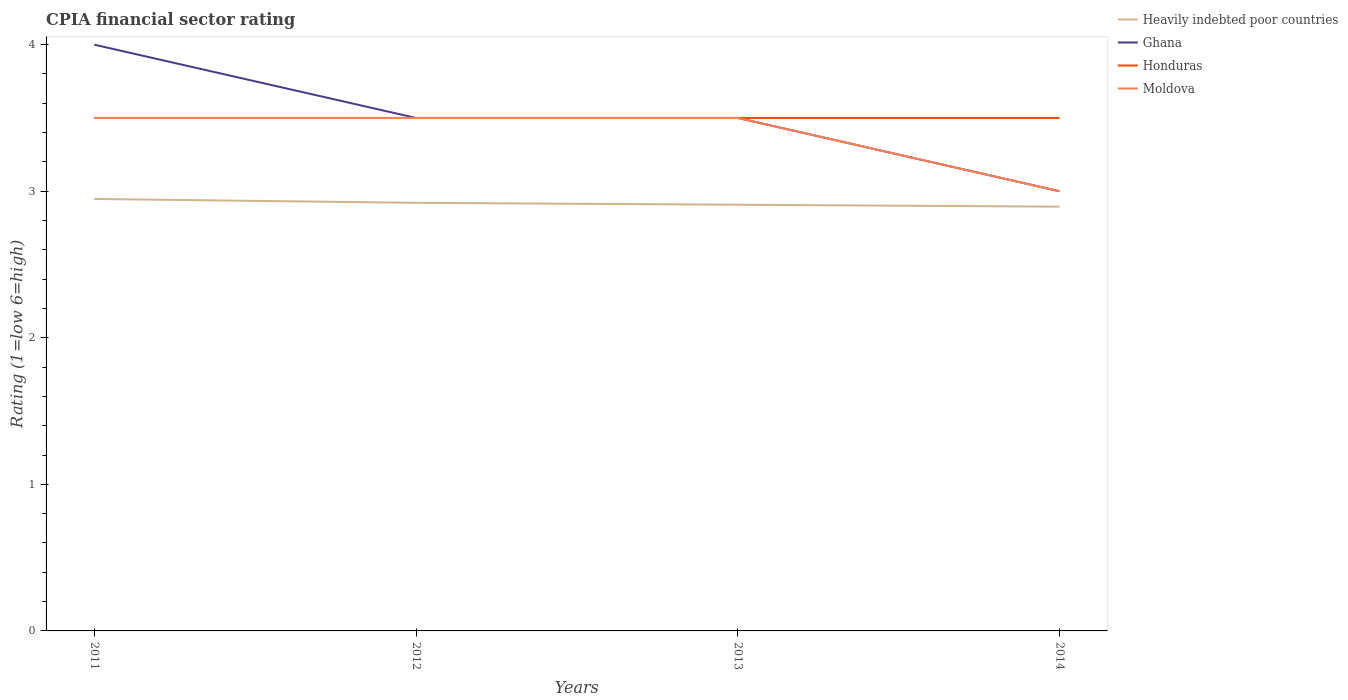How many different coloured lines are there?
Your response must be concise. 4. Does the line corresponding to Honduras intersect with the line corresponding to Moldova?
Keep it short and to the point. Yes. What is the total CPIA rating in Moldova in the graph?
Keep it short and to the point. 0. What is the difference between the highest and the second highest CPIA rating in Ghana?
Ensure brevity in your answer.  1. What is the difference between the highest and the lowest CPIA rating in Honduras?
Keep it short and to the point. 0. Is the CPIA rating in Moldova strictly greater than the CPIA rating in Honduras over the years?
Ensure brevity in your answer.  No. How many lines are there?
Ensure brevity in your answer.  4. Does the graph contain any zero values?
Offer a very short reply. No. Where does the legend appear in the graph?
Offer a very short reply. Top right. How many legend labels are there?
Your response must be concise. 4. What is the title of the graph?
Ensure brevity in your answer.  CPIA financial sector rating. Does "Greenland" appear as one of the legend labels in the graph?
Your response must be concise. No. What is the label or title of the X-axis?
Your response must be concise. Years. What is the label or title of the Y-axis?
Ensure brevity in your answer.  Rating (1=low 6=high). What is the Rating (1=low 6=high) of Heavily indebted poor countries in 2011?
Provide a succinct answer. 2.95. What is the Rating (1=low 6=high) in Ghana in 2011?
Offer a very short reply. 4. What is the Rating (1=low 6=high) of Heavily indebted poor countries in 2012?
Ensure brevity in your answer.  2.92. What is the Rating (1=low 6=high) in Ghana in 2012?
Provide a succinct answer. 3.5. What is the Rating (1=low 6=high) of Honduras in 2012?
Provide a succinct answer. 3.5. What is the Rating (1=low 6=high) in Moldova in 2012?
Provide a succinct answer. 3.5. What is the Rating (1=low 6=high) in Heavily indebted poor countries in 2013?
Ensure brevity in your answer.  2.91. What is the Rating (1=low 6=high) in Moldova in 2013?
Offer a very short reply. 3.5. What is the Rating (1=low 6=high) in Heavily indebted poor countries in 2014?
Offer a terse response. 2.89. What is the Rating (1=low 6=high) in Honduras in 2014?
Make the answer very short. 3.5. Across all years, what is the maximum Rating (1=low 6=high) in Heavily indebted poor countries?
Offer a terse response. 2.95. Across all years, what is the maximum Rating (1=low 6=high) in Ghana?
Provide a succinct answer. 4. Across all years, what is the maximum Rating (1=low 6=high) of Honduras?
Offer a very short reply. 3.5. Across all years, what is the minimum Rating (1=low 6=high) in Heavily indebted poor countries?
Ensure brevity in your answer.  2.89. Across all years, what is the minimum Rating (1=low 6=high) of Ghana?
Ensure brevity in your answer.  3. Across all years, what is the minimum Rating (1=low 6=high) in Moldova?
Provide a short and direct response. 3. What is the total Rating (1=low 6=high) in Heavily indebted poor countries in the graph?
Keep it short and to the point. 11.67. What is the difference between the Rating (1=low 6=high) of Heavily indebted poor countries in 2011 and that in 2012?
Your answer should be compact. 0.03. What is the difference between the Rating (1=low 6=high) of Honduras in 2011 and that in 2012?
Provide a succinct answer. 0. What is the difference between the Rating (1=low 6=high) of Moldova in 2011 and that in 2012?
Offer a very short reply. 0. What is the difference between the Rating (1=low 6=high) in Heavily indebted poor countries in 2011 and that in 2013?
Offer a terse response. 0.04. What is the difference between the Rating (1=low 6=high) of Honduras in 2011 and that in 2013?
Offer a terse response. 0. What is the difference between the Rating (1=low 6=high) in Heavily indebted poor countries in 2011 and that in 2014?
Offer a terse response. 0.05. What is the difference between the Rating (1=low 6=high) in Heavily indebted poor countries in 2012 and that in 2013?
Ensure brevity in your answer.  0.01. What is the difference between the Rating (1=low 6=high) in Moldova in 2012 and that in 2013?
Ensure brevity in your answer.  0. What is the difference between the Rating (1=low 6=high) in Heavily indebted poor countries in 2012 and that in 2014?
Your answer should be very brief. 0.03. What is the difference between the Rating (1=low 6=high) of Ghana in 2012 and that in 2014?
Your answer should be very brief. 0.5. What is the difference between the Rating (1=low 6=high) in Heavily indebted poor countries in 2013 and that in 2014?
Your answer should be very brief. 0.01. What is the difference between the Rating (1=low 6=high) in Heavily indebted poor countries in 2011 and the Rating (1=low 6=high) in Ghana in 2012?
Your answer should be very brief. -0.55. What is the difference between the Rating (1=low 6=high) of Heavily indebted poor countries in 2011 and the Rating (1=low 6=high) of Honduras in 2012?
Offer a very short reply. -0.55. What is the difference between the Rating (1=low 6=high) of Heavily indebted poor countries in 2011 and the Rating (1=low 6=high) of Moldova in 2012?
Make the answer very short. -0.55. What is the difference between the Rating (1=low 6=high) of Ghana in 2011 and the Rating (1=low 6=high) of Honduras in 2012?
Provide a succinct answer. 0.5. What is the difference between the Rating (1=low 6=high) of Ghana in 2011 and the Rating (1=low 6=high) of Moldova in 2012?
Provide a short and direct response. 0.5. What is the difference between the Rating (1=low 6=high) in Heavily indebted poor countries in 2011 and the Rating (1=low 6=high) in Ghana in 2013?
Offer a very short reply. -0.55. What is the difference between the Rating (1=low 6=high) in Heavily indebted poor countries in 2011 and the Rating (1=low 6=high) in Honduras in 2013?
Your answer should be very brief. -0.55. What is the difference between the Rating (1=low 6=high) of Heavily indebted poor countries in 2011 and the Rating (1=low 6=high) of Moldova in 2013?
Your answer should be very brief. -0.55. What is the difference between the Rating (1=low 6=high) in Ghana in 2011 and the Rating (1=low 6=high) in Moldova in 2013?
Offer a very short reply. 0.5. What is the difference between the Rating (1=low 6=high) of Heavily indebted poor countries in 2011 and the Rating (1=low 6=high) of Ghana in 2014?
Your response must be concise. -0.05. What is the difference between the Rating (1=low 6=high) in Heavily indebted poor countries in 2011 and the Rating (1=low 6=high) in Honduras in 2014?
Give a very brief answer. -0.55. What is the difference between the Rating (1=low 6=high) of Heavily indebted poor countries in 2011 and the Rating (1=low 6=high) of Moldova in 2014?
Your answer should be very brief. -0.05. What is the difference between the Rating (1=low 6=high) of Ghana in 2011 and the Rating (1=low 6=high) of Honduras in 2014?
Your response must be concise. 0.5. What is the difference between the Rating (1=low 6=high) of Heavily indebted poor countries in 2012 and the Rating (1=low 6=high) of Ghana in 2013?
Your response must be concise. -0.58. What is the difference between the Rating (1=low 6=high) of Heavily indebted poor countries in 2012 and the Rating (1=low 6=high) of Honduras in 2013?
Provide a short and direct response. -0.58. What is the difference between the Rating (1=low 6=high) in Heavily indebted poor countries in 2012 and the Rating (1=low 6=high) in Moldova in 2013?
Make the answer very short. -0.58. What is the difference between the Rating (1=low 6=high) in Honduras in 2012 and the Rating (1=low 6=high) in Moldova in 2013?
Provide a short and direct response. 0. What is the difference between the Rating (1=low 6=high) in Heavily indebted poor countries in 2012 and the Rating (1=low 6=high) in Ghana in 2014?
Ensure brevity in your answer.  -0.08. What is the difference between the Rating (1=low 6=high) in Heavily indebted poor countries in 2012 and the Rating (1=low 6=high) in Honduras in 2014?
Give a very brief answer. -0.58. What is the difference between the Rating (1=low 6=high) of Heavily indebted poor countries in 2012 and the Rating (1=low 6=high) of Moldova in 2014?
Make the answer very short. -0.08. What is the difference between the Rating (1=low 6=high) in Ghana in 2012 and the Rating (1=low 6=high) in Honduras in 2014?
Make the answer very short. 0. What is the difference between the Rating (1=low 6=high) in Honduras in 2012 and the Rating (1=low 6=high) in Moldova in 2014?
Provide a short and direct response. 0.5. What is the difference between the Rating (1=low 6=high) of Heavily indebted poor countries in 2013 and the Rating (1=low 6=high) of Ghana in 2014?
Your answer should be very brief. -0.09. What is the difference between the Rating (1=low 6=high) of Heavily indebted poor countries in 2013 and the Rating (1=low 6=high) of Honduras in 2014?
Offer a terse response. -0.59. What is the difference between the Rating (1=low 6=high) of Heavily indebted poor countries in 2013 and the Rating (1=low 6=high) of Moldova in 2014?
Make the answer very short. -0.09. What is the difference between the Rating (1=low 6=high) of Ghana in 2013 and the Rating (1=low 6=high) of Moldova in 2014?
Your response must be concise. 0.5. What is the difference between the Rating (1=low 6=high) in Honduras in 2013 and the Rating (1=low 6=high) in Moldova in 2014?
Ensure brevity in your answer.  0.5. What is the average Rating (1=low 6=high) of Heavily indebted poor countries per year?
Keep it short and to the point. 2.92. What is the average Rating (1=low 6=high) of Ghana per year?
Provide a short and direct response. 3.5. What is the average Rating (1=low 6=high) in Moldova per year?
Your answer should be very brief. 3.38. In the year 2011, what is the difference between the Rating (1=low 6=high) of Heavily indebted poor countries and Rating (1=low 6=high) of Ghana?
Offer a very short reply. -1.05. In the year 2011, what is the difference between the Rating (1=low 6=high) of Heavily indebted poor countries and Rating (1=low 6=high) of Honduras?
Your response must be concise. -0.55. In the year 2011, what is the difference between the Rating (1=low 6=high) of Heavily indebted poor countries and Rating (1=low 6=high) of Moldova?
Your response must be concise. -0.55. In the year 2012, what is the difference between the Rating (1=low 6=high) in Heavily indebted poor countries and Rating (1=low 6=high) in Ghana?
Provide a succinct answer. -0.58. In the year 2012, what is the difference between the Rating (1=low 6=high) in Heavily indebted poor countries and Rating (1=low 6=high) in Honduras?
Offer a terse response. -0.58. In the year 2012, what is the difference between the Rating (1=low 6=high) of Heavily indebted poor countries and Rating (1=low 6=high) of Moldova?
Your answer should be very brief. -0.58. In the year 2013, what is the difference between the Rating (1=low 6=high) in Heavily indebted poor countries and Rating (1=low 6=high) in Ghana?
Offer a terse response. -0.59. In the year 2013, what is the difference between the Rating (1=low 6=high) in Heavily indebted poor countries and Rating (1=low 6=high) in Honduras?
Provide a short and direct response. -0.59. In the year 2013, what is the difference between the Rating (1=low 6=high) of Heavily indebted poor countries and Rating (1=low 6=high) of Moldova?
Make the answer very short. -0.59. In the year 2013, what is the difference between the Rating (1=low 6=high) in Ghana and Rating (1=low 6=high) in Honduras?
Keep it short and to the point. 0. In the year 2014, what is the difference between the Rating (1=low 6=high) in Heavily indebted poor countries and Rating (1=low 6=high) in Ghana?
Provide a succinct answer. -0.11. In the year 2014, what is the difference between the Rating (1=low 6=high) of Heavily indebted poor countries and Rating (1=low 6=high) of Honduras?
Provide a short and direct response. -0.61. In the year 2014, what is the difference between the Rating (1=low 6=high) in Heavily indebted poor countries and Rating (1=low 6=high) in Moldova?
Keep it short and to the point. -0.11. What is the ratio of the Rating (1=low 6=high) in Ghana in 2011 to that in 2012?
Keep it short and to the point. 1.14. What is the ratio of the Rating (1=low 6=high) in Moldova in 2011 to that in 2012?
Provide a short and direct response. 1. What is the ratio of the Rating (1=low 6=high) of Heavily indebted poor countries in 2011 to that in 2013?
Provide a succinct answer. 1.01. What is the ratio of the Rating (1=low 6=high) of Ghana in 2011 to that in 2013?
Keep it short and to the point. 1.14. What is the ratio of the Rating (1=low 6=high) in Honduras in 2011 to that in 2013?
Offer a very short reply. 1. What is the ratio of the Rating (1=low 6=high) of Heavily indebted poor countries in 2011 to that in 2014?
Make the answer very short. 1.02. What is the ratio of the Rating (1=low 6=high) of Heavily indebted poor countries in 2012 to that in 2013?
Keep it short and to the point. 1. What is the ratio of the Rating (1=low 6=high) in Moldova in 2012 to that in 2013?
Your answer should be very brief. 1. What is the ratio of the Rating (1=low 6=high) in Heavily indebted poor countries in 2012 to that in 2014?
Ensure brevity in your answer.  1.01. What is the ratio of the Rating (1=low 6=high) of Moldova in 2012 to that in 2014?
Give a very brief answer. 1.17. What is the ratio of the Rating (1=low 6=high) in Ghana in 2013 to that in 2014?
Your response must be concise. 1.17. What is the ratio of the Rating (1=low 6=high) of Honduras in 2013 to that in 2014?
Ensure brevity in your answer.  1. What is the difference between the highest and the second highest Rating (1=low 6=high) of Heavily indebted poor countries?
Give a very brief answer. 0.03. What is the difference between the highest and the second highest Rating (1=low 6=high) of Moldova?
Provide a short and direct response. 0. What is the difference between the highest and the lowest Rating (1=low 6=high) in Heavily indebted poor countries?
Make the answer very short. 0.05. What is the difference between the highest and the lowest Rating (1=low 6=high) in Ghana?
Provide a short and direct response. 1. What is the difference between the highest and the lowest Rating (1=low 6=high) in Honduras?
Keep it short and to the point. 0. What is the difference between the highest and the lowest Rating (1=low 6=high) of Moldova?
Provide a succinct answer. 0.5. 